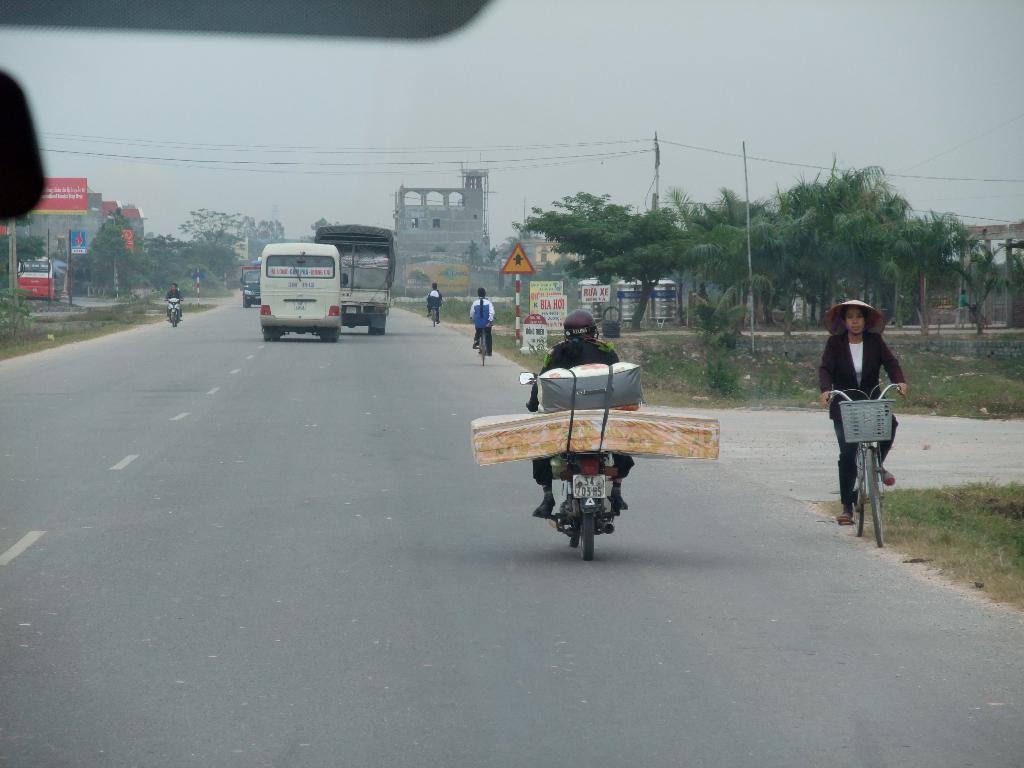Please provide a concise description of this image. In this image I see few vehicles and I see few persons who are on the bikes and I see road on which there are white lines and I see the green grass and I see a sign board over here. In the background I see number of trees, wires, buildings and the sky. 